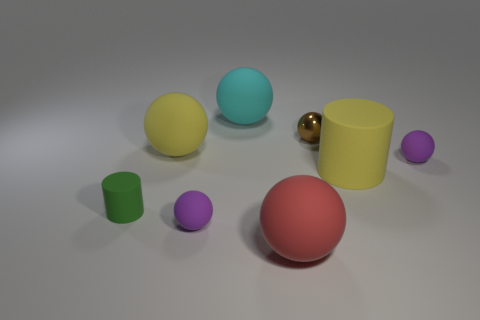Are there any big red things of the same shape as the small metallic object?
Your answer should be compact. Yes. What number of other objects are the same color as the small rubber cylinder?
Your response must be concise. 0. There is a big sphere in front of the tiny rubber ball to the right of the small rubber sphere left of the big red ball; what is its color?
Provide a succinct answer. Red. Are there an equal number of big rubber objects that are left of the small cylinder and small yellow matte things?
Offer a very short reply. Yes. Does the purple sphere that is on the right side of the shiny ball have the same size as the tiny cylinder?
Your response must be concise. Yes. What number of tiny red rubber blocks are there?
Your answer should be very brief. 0. What number of matte objects are in front of the large yellow matte sphere and left of the large cyan matte sphere?
Your answer should be very brief. 2. Are there any purple spheres that have the same material as the cyan thing?
Your answer should be very brief. Yes. What is the material of the purple thing that is to the right of the large yellow rubber thing that is on the right side of the cyan matte ball?
Your answer should be very brief. Rubber. Are there the same number of rubber objects in front of the cyan ball and small purple objects that are behind the small cylinder?
Your answer should be very brief. No. 